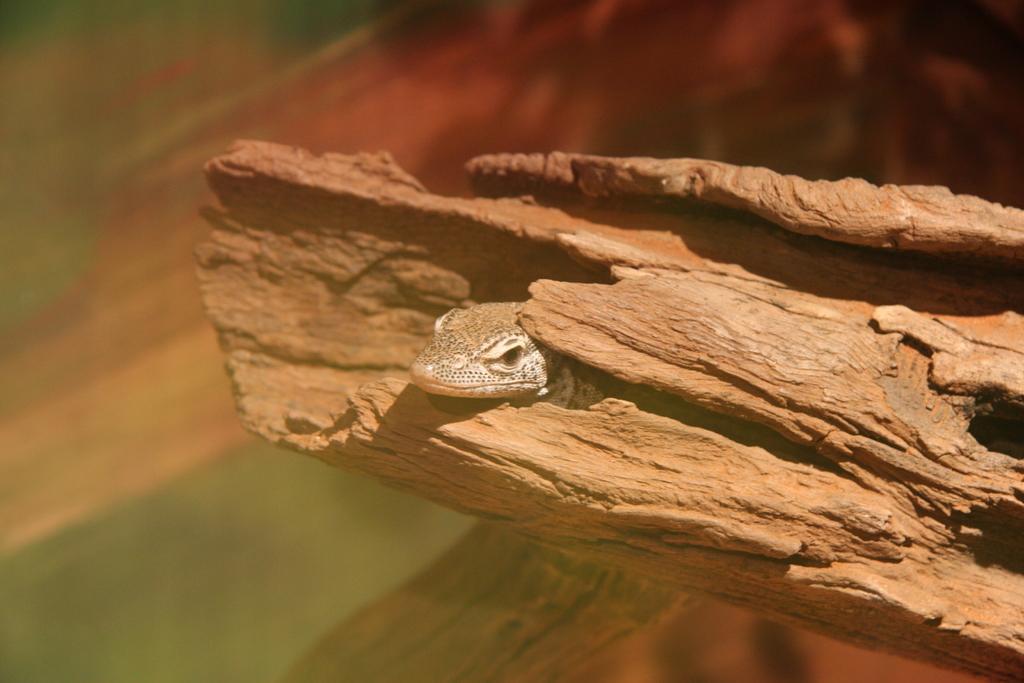Can you describe this image briefly? This picture shows a reptile in the tree bark. 